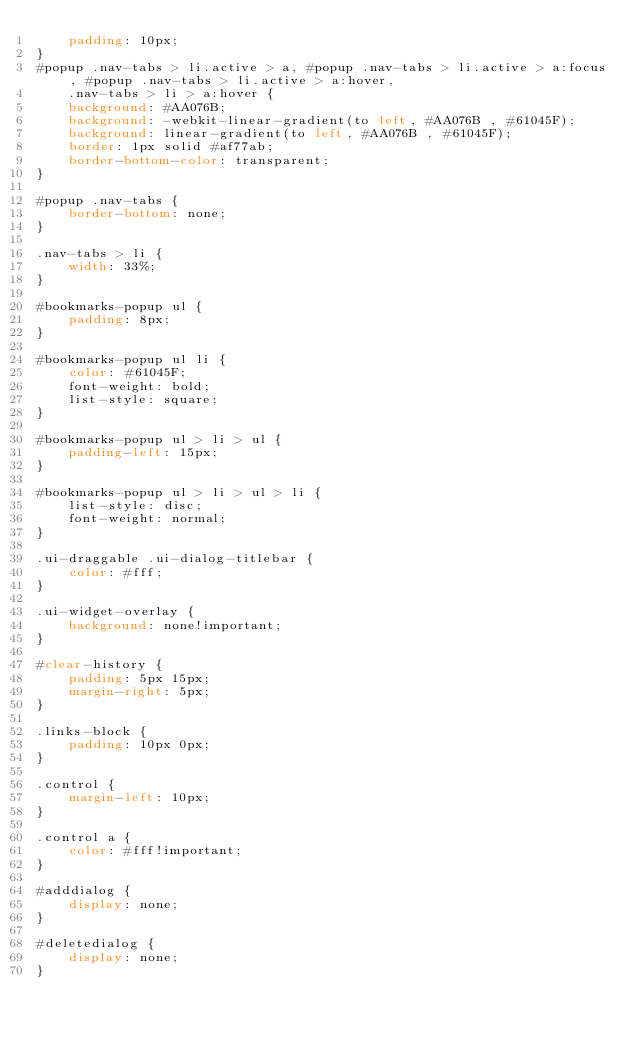Convert code to text. <code><loc_0><loc_0><loc_500><loc_500><_CSS_>    padding: 10px;
}
#popup .nav-tabs > li.active > a, #popup .nav-tabs > li.active > a:focus, #popup .nav-tabs > li.active > a:hover,
    .nav-tabs > li > a:hover {
    background: #AA076B;
    background: -webkit-linear-gradient(to left, #AA076B , #61045F);
    background: linear-gradient(to left, #AA076B , #61045F);
    border: 1px solid #af77ab;
    border-bottom-color: transparent;
}

#popup .nav-tabs {
    border-bottom: none;
}

.nav-tabs > li {
    width: 33%;
}

#bookmarks-popup ul {
    padding: 8px;
}

#bookmarks-popup ul li {
    color: #61045F;
    font-weight: bold;
    list-style: square;
}

#bookmarks-popup ul > li > ul {
    padding-left: 15px;
}

#bookmarks-popup ul > li > ul > li {
    list-style: disc;
    font-weight: normal;
}

.ui-draggable .ui-dialog-titlebar {
    color: #fff;
}

.ui-widget-overlay {
    background: none!important;
}

#clear-history {
    padding: 5px 15px;
    margin-right: 5px;
}

.links-block {
    padding: 10px 0px;
}

.control {
    margin-left: 10px;
}

.control a {
    color: #fff!important;
}

#adddialog {
    display: none;
}

#deletedialog {
    display: none;
}


</code> 